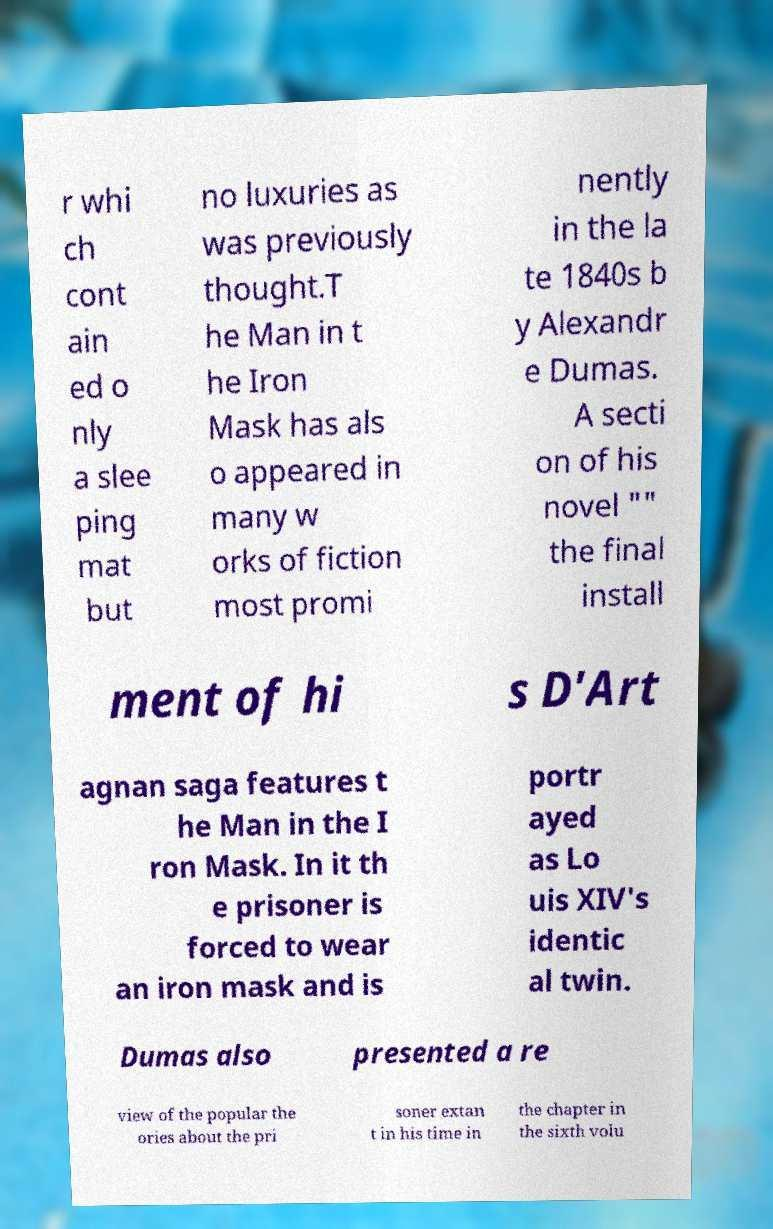Please read and relay the text visible in this image. What does it say? r whi ch cont ain ed o nly a slee ping mat but no luxuries as was previously thought.T he Man in t he Iron Mask has als o appeared in many w orks of fiction most promi nently in the la te 1840s b y Alexandr e Dumas. A secti on of his novel "" the final install ment of hi s D'Art agnan saga features t he Man in the I ron Mask. In it th e prisoner is forced to wear an iron mask and is portr ayed as Lo uis XIV's identic al twin. Dumas also presented a re view of the popular the ories about the pri soner extan t in his time in the chapter in the sixth volu 